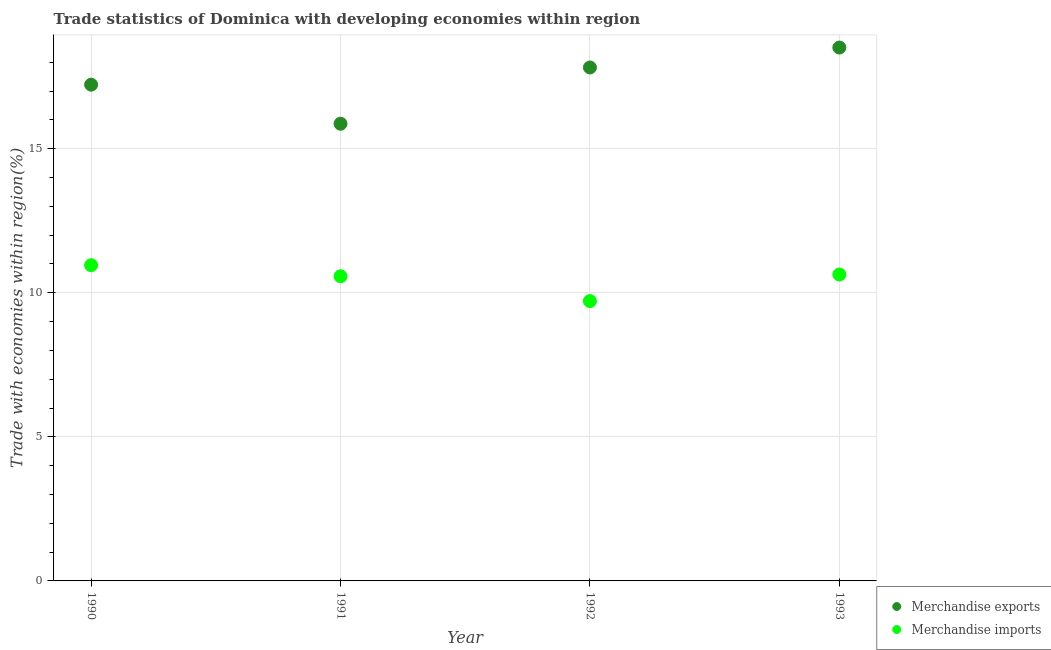What is the merchandise exports in 1993?
Offer a terse response. 18.51. Across all years, what is the maximum merchandise exports?
Your answer should be compact. 18.51. Across all years, what is the minimum merchandise imports?
Offer a very short reply. 9.71. In which year was the merchandise exports maximum?
Ensure brevity in your answer.  1993. In which year was the merchandise exports minimum?
Provide a succinct answer. 1991. What is the total merchandise exports in the graph?
Offer a terse response. 69.41. What is the difference between the merchandise imports in 1990 and that in 1993?
Give a very brief answer. 0.32. What is the difference between the merchandise imports in 1990 and the merchandise exports in 1991?
Provide a short and direct response. -4.91. What is the average merchandise exports per year?
Provide a succinct answer. 17.35. In the year 1992, what is the difference between the merchandise imports and merchandise exports?
Your answer should be very brief. -8.11. What is the ratio of the merchandise exports in 1991 to that in 1993?
Give a very brief answer. 0.86. Is the merchandise imports in 1991 less than that in 1993?
Keep it short and to the point. Yes. Is the difference between the merchandise imports in 1990 and 1991 greater than the difference between the merchandise exports in 1990 and 1991?
Ensure brevity in your answer.  No. What is the difference between the highest and the second highest merchandise imports?
Ensure brevity in your answer.  0.32. What is the difference between the highest and the lowest merchandise imports?
Your response must be concise. 1.24. Is the sum of the merchandise exports in 1992 and 1993 greater than the maximum merchandise imports across all years?
Ensure brevity in your answer.  Yes. Is the merchandise exports strictly greater than the merchandise imports over the years?
Offer a very short reply. Yes. Is the merchandise exports strictly less than the merchandise imports over the years?
Keep it short and to the point. No. How many dotlines are there?
Keep it short and to the point. 2. Does the graph contain grids?
Provide a succinct answer. Yes. What is the title of the graph?
Your response must be concise. Trade statistics of Dominica with developing economies within region. What is the label or title of the X-axis?
Offer a very short reply. Year. What is the label or title of the Y-axis?
Offer a terse response. Trade with economies within region(%). What is the Trade with economies within region(%) of Merchandise exports in 1990?
Offer a terse response. 17.22. What is the Trade with economies within region(%) in Merchandise imports in 1990?
Give a very brief answer. 10.96. What is the Trade with economies within region(%) of Merchandise exports in 1991?
Give a very brief answer. 15.86. What is the Trade with economies within region(%) in Merchandise imports in 1991?
Your response must be concise. 10.57. What is the Trade with economies within region(%) of Merchandise exports in 1992?
Give a very brief answer. 17.82. What is the Trade with economies within region(%) in Merchandise imports in 1992?
Give a very brief answer. 9.71. What is the Trade with economies within region(%) in Merchandise exports in 1993?
Your answer should be very brief. 18.51. What is the Trade with economies within region(%) in Merchandise imports in 1993?
Your response must be concise. 10.63. Across all years, what is the maximum Trade with economies within region(%) in Merchandise exports?
Your answer should be compact. 18.51. Across all years, what is the maximum Trade with economies within region(%) of Merchandise imports?
Your answer should be very brief. 10.96. Across all years, what is the minimum Trade with economies within region(%) in Merchandise exports?
Offer a very short reply. 15.86. Across all years, what is the minimum Trade with economies within region(%) of Merchandise imports?
Offer a very short reply. 9.71. What is the total Trade with economies within region(%) of Merchandise exports in the graph?
Offer a very short reply. 69.41. What is the total Trade with economies within region(%) of Merchandise imports in the graph?
Ensure brevity in your answer.  41.87. What is the difference between the Trade with economies within region(%) in Merchandise exports in 1990 and that in 1991?
Your answer should be compact. 1.36. What is the difference between the Trade with economies within region(%) in Merchandise imports in 1990 and that in 1991?
Make the answer very short. 0.38. What is the difference between the Trade with economies within region(%) of Merchandise exports in 1990 and that in 1992?
Offer a very short reply. -0.6. What is the difference between the Trade with economies within region(%) of Merchandise imports in 1990 and that in 1992?
Provide a succinct answer. 1.24. What is the difference between the Trade with economies within region(%) of Merchandise exports in 1990 and that in 1993?
Your answer should be compact. -1.29. What is the difference between the Trade with economies within region(%) of Merchandise imports in 1990 and that in 1993?
Offer a terse response. 0.32. What is the difference between the Trade with economies within region(%) of Merchandise exports in 1991 and that in 1992?
Ensure brevity in your answer.  -1.95. What is the difference between the Trade with economies within region(%) in Merchandise imports in 1991 and that in 1992?
Make the answer very short. 0.86. What is the difference between the Trade with economies within region(%) in Merchandise exports in 1991 and that in 1993?
Make the answer very short. -2.64. What is the difference between the Trade with economies within region(%) of Merchandise imports in 1991 and that in 1993?
Your answer should be compact. -0.06. What is the difference between the Trade with economies within region(%) in Merchandise exports in 1992 and that in 1993?
Your answer should be very brief. -0.69. What is the difference between the Trade with economies within region(%) of Merchandise imports in 1992 and that in 1993?
Offer a very short reply. -0.92. What is the difference between the Trade with economies within region(%) in Merchandise exports in 1990 and the Trade with economies within region(%) in Merchandise imports in 1991?
Provide a short and direct response. 6.65. What is the difference between the Trade with economies within region(%) in Merchandise exports in 1990 and the Trade with economies within region(%) in Merchandise imports in 1992?
Offer a very short reply. 7.51. What is the difference between the Trade with economies within region(%) in Merchandise exports in 1990 and the Trade with economies within region(%) in Merchandise imports in 1993?
Provide a short and direct response. 6.59. What is the difference between the Trade with economies within region(%) in Merchandise exports in 1991 and the Trade with economies within region(%) in Merchandise imports in 1992?
Provide a succinct answer. 6.15. What is the difference between the Trade with economies within region(%) of Merchandise exports in 1991 and the Trade with economies within region(%) of Merchandise imports in 1993?
Give a very brief answer. 5.23. What is the difference between the Trade with economies within region(%) of Merchandise exports in 1992 and the Trade with economies within region(%) of Merchandise imports in 1993?
Keep it short and to the point. 7.18. What is the average Trade with economies within region(%) of Merchandise exports per year?
Give a very brief answer. 17.35. What is the average Trade with economies within region(%) of Merchandise imports per year?
Give a very brief answer. 10.47. In the year 1990, what is the difference between the Trade with economies within region(%) in Merchandise exports and Trade with economies within region(%) in Merchandise imports?
Provide a short and direct response. 6.26. In the year 1991, what is the difference between the Trade with economies within region(%) in Merchandise exports and Trade with economies within region(%) in Merchandise imports?
Provide a short and direct response. 5.29. In the year 1992, what is the difference between the Trade with economies within region(%) of Merchandise exports and Trade with economies within region(%) of Merchandise imports?
Provide a succinct answer. 8.11. In the year 1993, what is the difference between the Trade with economies within region(%) of Merchandise exports and Trade with economies within region(%) of Merchandise imports?
Your answer should be very brief. 7.87. What is the ratio of the Trade with economies within region(%) in Merchandise exports in 1990 to that in 1991?
Provide a short and direct response. 1.09. What is the ratio of the Trade with economies within region(%) of Merchandise imports in 1990 to that in 1991?
Your response must be concise. 1.04. What is the ratio of the Trade with economies within region(%) of Merchandise exports in 1990 to that in 1992?
Provide a succinct answer. 0.97. What is the ratio of the Trade with economies within region(%) of Merchandise imports in 1990 to that in 1992?
Your answer should be compact. 1.13. What is the ratio of the Trade with economies within region(%) of Merchandise exports in 1990 to that in 1993?
Make the answer very short. 0.93. What is the ratio of the Trade with economies within region(%) in Merchandise imports in 1990 to that in 1993?
Offer a terse response. 1.03. What is the ratio of the Trade with economies within region(%) of Merchandise exports in 1991 to that in 1992?
Provide a succinct answer. 0.89. What is the ratio of the Trade with economies within region(%) in Merchandise imports in 1991 to that in 1992?
Keep it short and to the point. 1.09. What is the ratio of the Trade with economies within region(%) of Merchandise exports in 1991 to that in 1993?
Your answer should be compact. 0.86. What is the ratio of the Trade with economies within region(%) of Merchandise exports in 1992 to that in 1993?
Give a very brief answer. 0.96. What is the ratio of the Trade with economies within region(%) in Merchandise imports in 1992 to that in 1993?
Make the answer very short. 0.91. What is the difference between the highest and the second highest Trade with economies within region(%) in Merchandise exports?
Make the answer very short. 0.69. What is the difference between the highest and the second highest Trade with economies within region(%) of Merchandise imports?
Provide a short and direct response. 0.32. What is the difference between the highest and the lowest Trade with economies within region(%) in Merchandise exports?
Your answer should be very brief. 2.64. What is the difference between the highest and the lowest Trade with economies within region(%) of Merchandise imports?
Make the answer very short. 1.24. 